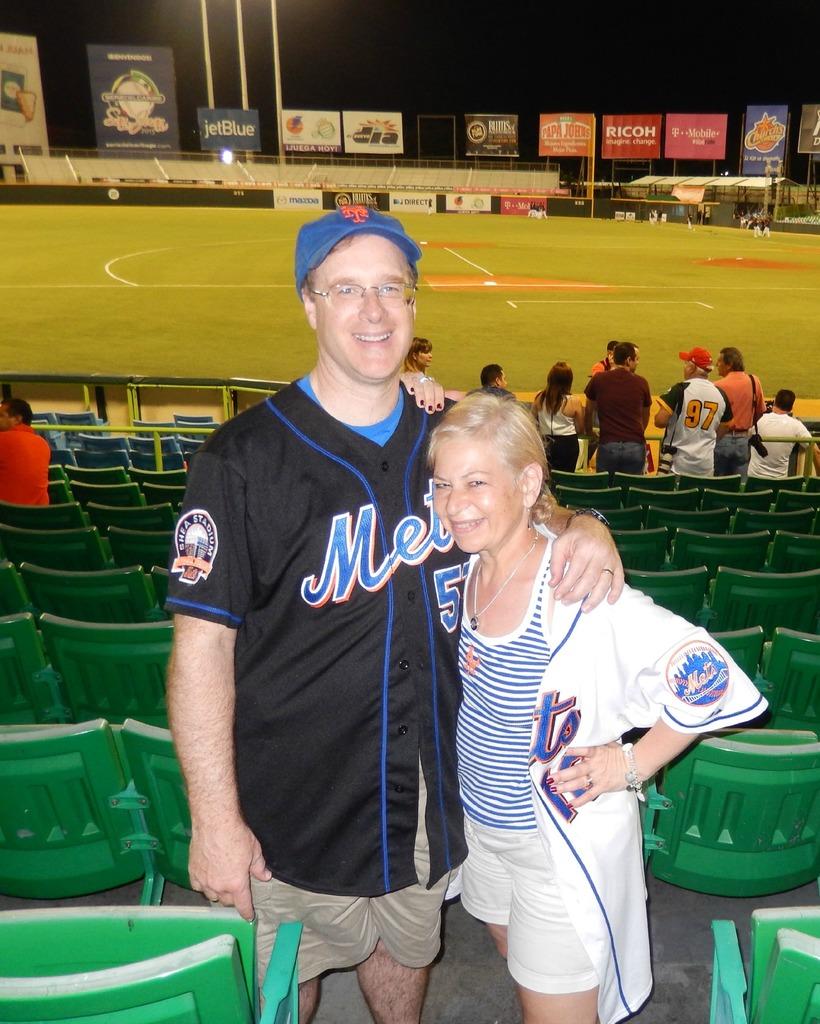What mlb team is displayed on the jersey?
Ensure brevity in your answer.  Mets. What brand is advertised on the orange sign in the outfield?
Your answer should be very brief. Papa johns. 